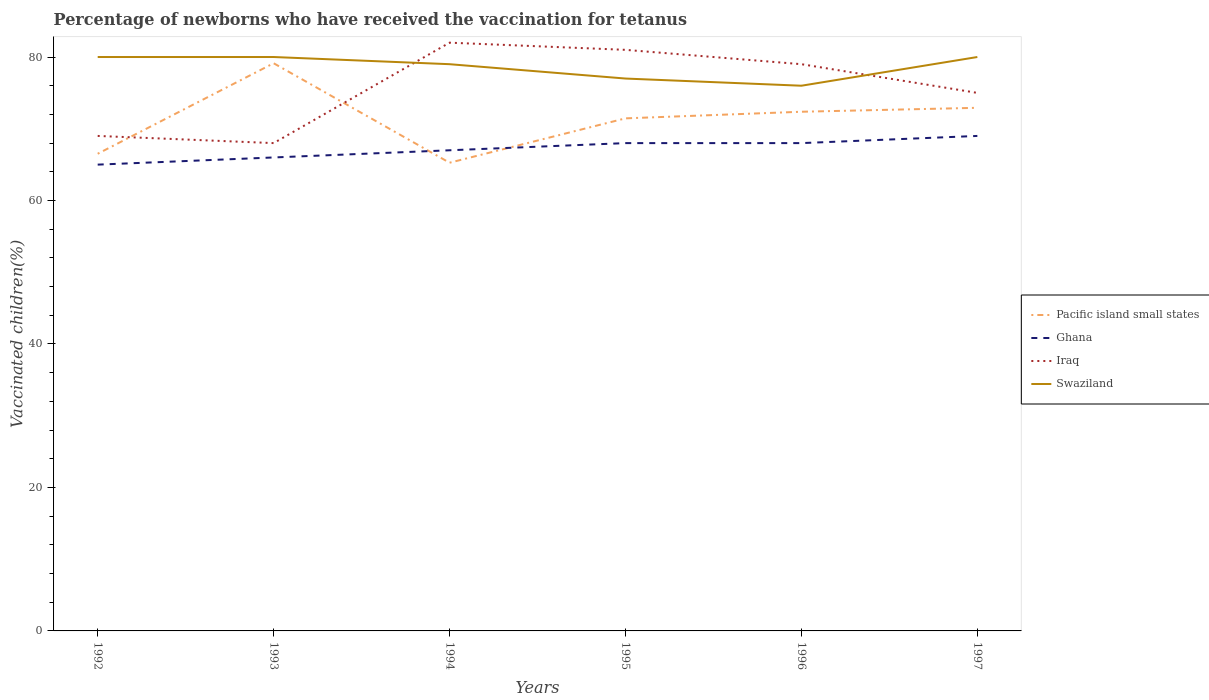Across all years, what is the maximum percentage of vaccinated children in Pacific island small states?
Make the answer very short. 65.27. What is the total percentage of vaccinated children in Pacific island small states in the graph?
Make the answer very short. -0.55. What is the difference between the highest and the second highest percentage of vaccinated children in Iraq?
Your answer should be compact. 14. Is the percentage of vaccinated children in Ghana strictly greater than the percentage of vaccinated children in Pacific island small states over the years?
Provide a short and direct response. No. How many years are there in the graph?
Keep it short and to the point. 6. What is the difference between two consecutive major ticks on the Y-axis?
Your answer should be compact. 20. Does the graph contain any zero values?
Give a very brief answer. No. Where does the legend appear in the graph?
Provide a short and direct response. Center right. How are the legend labels stacked?
Provide a succinct answer. Vertical. What is the title of the graph?
Ensure brevity in your answer.  Percentage of newborns who have received the vaccination for tetanus. Does "Bosnia and Herzegovina" appear as one of the legend labels in the graph?
Your answer should be very brief. No. What is the label or title of the X-axis?
Give a very brief answer. Years. What is the label or title of the Y-axis?
Offer a very short reply. Vaccinated children(%). What is the Vaccinated children(%) in Pacific island small states in 1992?
Provide a short and direct response. 66.51. What is the Vaccinated children(%) in Ghana in 1992?
Keep it short and to the point. 65. What is the Vaccinated children(%) of Iraq in 1992?
Make the answer very short. 69. What is the Vaccinated children(%) in Swaziland in 1992?
Your answer should be compact. 80. What is the Vaccinated children(%) in Pacific island small states in 1993?
Your answer should be very brief. 79.13. What is the Vaccinated children(%) in Swaziland in 1993?
Give a very brief answer. 80. What is the Vaccinated children(%) in Pacific island small states in 1994?
Offer a terse response. 65.27. What is the Vaccinated children(%) in Ghana in 1994?
Make the answer very short. 67. What is the Vaccinated children(%) in Swaziland in 1994?
Your answer should be compact. 79. What is the Vaccinated children(%) in Pacific island small states in 1995?
Keep it short and to the point. 71.45. What is the Vaccinated children(%) of Ghana in 1995?
Offer a terse response. 68. What is the Vaccinated children(%) in Iraq in 1995?
Give a very brief answer. 81. What is the Vaccinated children(%) of Pacific island small states in 1996?
Make the answer very short. 72.37. What is the Vaccinated children(%) in Iraq in 1996?
Ensure brevity in your answer.  79. What is the Vaccinated children(%) in Pacific island small states in 1997?
Provide a succinct answer. 72.92. What is the Vaccinated children(%) of Iraq in 1997?
Your answer should be very brief. 75. Across all years, what is the maximum Vaccinated children(%) in Pacific island small states?
Provide a short and direct response. 79.13. Across all years, what is the maximum Vaccinated children(%) of Iraq?
Give a very brief answer. 82. Across all years, what is the maximum Vaccinated children(%) in Swaziland?
Give a very brief answer. 80. Across all years, what is the minimum Vaccinated children(%) of Pacific island small states?
Offer a terse response. 65.27. What is the total Vaccinated children(%) of Pacific island small states in the graph?
Keep it short and to the point. 427.66. What is the total Vaccinated children(%) of Ghana in the graph?
Ensure brevity in your answer.  403. What is the total Vaccinated children(%) of Iraq in the graph?
Your answer should be very brief. 454. What is the total Vaccinated children(%) of Swaziland in the graph?
Offer a terse response. 472. What is the difference between the Vaccinated children(%) of Pacific island small states in 1992 and that in 1993?
Make the answer very short. -12.62. What is the difference between the Vaccinated children(%) in Ghana in 1992 and that in 1993?
Provide a succinct answer. -1. What is the difference between the Vaccinated children(%) in Iraq in 1992 and that in 1993?
Your answer should be very brief. 1. What is the difference between the Vaccinated children(%) of Pacific island small states in 1992 and that in 1994?
Your answer should be very brief. 1.25. What is the difference between the Vaccinated children(%) in Pacific island small states in 1992 and that in 1995?
Make the answer very short. -4.93. What is the difference between the Vaccinated children(%) of Ghana in 1992 and that in 1995?
Provide a succinct answer. -3. What is the difference between the Vaccinated children(%) in Pacific island small states in 1992 and that in 1996?
Give a very brief answer. -5.86. What is the difference between the Vaccinated children(%) in Ghana in 1992 and that in 1996?
Keep it short and to the point. -3. What is the difference between the Vaccinated children(%) in Iraq in 1992 and that in 1996?
Provide a short and direct response. -10. What is the difference between the Vaccinated children(%) of Swaziland in 1992 and that in 1996?
Offer a terse response. 4. What is the difference between the Vaccinated children(%) of Pacific island small states in 1992 and that in 1997?
Ensure brevity in your answer.  -6.41. What is the difference between the Vaccinated children(%) of Iraq in 1992 and that in 1997?
Keep it short and to the point. -6. What is the difference between the Vaccinated children(%) of Swaziland in 1992 and that in 1997?
Provide a short and direct response. 0. What is the difference between the Vaccinated children(%) of Pacific island small states in 1993 and that in 1994?
Offer a very short reply. 13.87. What is the difference between the Vaccinated children(%) of Pacific island small states in 1993 and that in 1995?
Ensure brevity in your answer.  7.68. What is the difference between the Vaccinated children(%) in Ghana in 1993 and that in 1995?
Your response must be concise. -2. What is the difference between the Vaccinated children(%) of Pacific island small states in 1993 and that in 1996?
Keep it short and to the point. 6.76. What is the difference between the Vaccinated children(%) of Iraq in 1993 and that in 1996?
Give a very brief answer. -11. What is the difference between the Vaccinated children(%) of Swaziland in 1993 and that in 1996?
Ensure brevity in your answer.  4. What is the difference between the Vaccinated children(%) of Pacific island small states in 1993 and that in 1997?
Give a very brief answer. 6.21. What is the difference between the Vaccinated children(%) of Swaziland in 1993 and that in 1997?
Provide a succinct answer. 0. What is the difference between the Vaccinated children(%) in Pacific island small states in 1994 and that in 1995?
Your response must be concise. -6.18. What is the difference between the Vaccinated children(%) in Swaziland in 1994 and that in 1995?
Offer a terse response. 2. What is the difference between the Vaccinated children(%) of Pacific island small states in 1994 and that in 1996?
Your answer should be compact. -7.11. What is the difference between the Vaccinated children(%) in Ghana in 1994 and that in 1996?
Keep it short and to the point. -1. What is the difference between the Vaccinated children(%) of Pacific island small states in 1994 and that in 1997?
Keep it short and to the point. -7.66. What is the difference between the Vaccinated children(%) of Ghana in 1994 and that in 1997?
Your response must be concise. -2. What is the difference between the Vaccinated children(%) in Pacific island small states in 1995 and that in 1996?
Make the answer very short. -0.92. What is the difference between the Vaccinated children(%) in Iraq in 1995 and that in 1996?
Your answer should be very brief. 2. What is the difference between the Vaccinated children(%) of Swaziland in 1995 and that in 1996?
Your answer should be compact. 1. What is the difference between the Vaccinated children(%) of Pacific island small states in 1995 and that in 1997?
Make the answer very short. -1.47. What is the difference between the Vaccinated children(%) of Ghana in 1995 and that in 1997?
Provide a short and direct response. -1. What is the difference between the Vaccinated children(%) of Iraq in 1995 and that in 1997?
Ensure brevity in your answer.  6. What is the difference between the Vaccinated children(%) in Swaziland in 1995 and that in 1997?
Make the answer very short. -3. What is the difference between the Vaccinated children(%) in Pacific island small states in 1996 and that in 1997?
Give a very brief answer. -0.55. What is the difference between the Vaccinated children(%) in Ghana in 1996 and that in 1997?
Provide a short and direct response. -1. What is the difference between the Vaccinated children(%) of Iraq in 1996 and that in 1997?
Your answer should be compact. 4. What is the difference between the Vaccinated children(%) of Swaziland in 1996 and that in 1997?
Ensure brevity in your answer.  -4. What is the difference between the Vaccinated children(%) in Pacific island small states in 1992 and the Vaccinated children(%) in Ghana in 1993?
Your answer should be compact. 0.51. What is the difference between the Vaccinated children(%) of Pacific island small states in 1992 and the Vaccinated children(%) of Iraq in 1993?
Provide a succinct answer. -1.49. What is the difference between the Vaccinated children(%) in Pacific island small states in 1992 and the Vaccinated children(%) in Swaziland in 1993?
Make the answer very short. -13.49. What is the difference between the Vaccinated children(%) of Iraq in 1992 and the Vaccinated children(%) of Swaziland in 1993?
Make the answer very short. -11. What is the difference between the Vaccinated children(%) in Pacific island small states in 1992 and the Vaccinated children(%) in Ghana in 1994?
Provide a short and direct response. -0.49. What is the difference between the Vaccinated children(%) of Pacific island small states in 1992 and the Vaccinated children(%) of Iraq in 1994?
Your answer should be compact. -15.49. What is the difference between the Vaccinated children(%) of Pacific island small states in 1992 and the Vaccinated children(%) of Swaziland in 1994?
Offer a very short reply. -12.49. What is the difference between the Vaccinated children(%) of Ghana in 1992 and the Vaccinated children(%) of Iraq in 1994?
Give a very brief answer. -17. What is the difference between the Vaccinated children(%) in Iraq in 1992 and the Vaccinated children(%) in Swaziland in 1994?
Your answer should be compact. -10. What is the difference between the Vaccinated children(%) in Pacific island small states in 1992 and the Vaccinated children(%) in Ghana in 1995?
Offer a terse response. -1.49. What is the difference between the Vaccinated children(%) of Pacific island small states in 1992 and the Vaccinated children(%) of Iraq in 1995?
Give a very brief answer. -14.49. What is the difference between the Vaccinated children(%) of Pacific island small states in 1992 and the Vaccinated children(%) of Swaziland in 1995?
Your answer should be compact. -10.49. What is the difference between the Vaccinated children(%) of Ghana in 1992 and the Vaccinated children(%) of Iraq in 1995?
Give a very brief answer. -16. What is the difference between the Vaccinated children(%) of Iraq in 1992 and the Vaccinated children(%) of Swaziland in 1995?
Ensure brevity in your answer.  -8. What is the difference between the Vaccinated children(%) of Pacific island small states in 1992 and the Vaccinated children(%) of Ghana in 1996?
Your answer should be very brief. -1.49. What is the difference between the Vaccinated children(%) of Pacific island small states in 1992 and the Vaccinated children(%) of Iraq in 1996?
Your response must be concise. -12.49. What is the difference between the Vaccinated children(%) of Pacific island small states in 1992 and the Vaccinated children(%) of Swaziland in 1996?
Provide a succinct answer. -9.49. What is the difference between the Vaccinated children(%) of Iraq in 1992 and the Vaccinated children(%) of Swaziland in 1996?
Offer a very short reply. -7. What is the difference between the Vaccinated children(%) of Pacific island small states in 1992 and the Vaccinated children(%) of Ghana in 1997?
Provide a short and direct response. -2.49. What is the difference between the Vaccinated children(%) of Pacific island small states in 1992 and the Vaccinated children(%) of Iraq in 1997?
Offer a terse response. -8.49. What is the difference between the Vaccinated children(%) of Pacific island small states in 1992 and the Vaccinated children(%) of Swaziland in 1997?
Give a very brief answer. -13.49. What is the difference between the Vaccinated children(%) of Ghana in 1992 and the Vaccinated children(%) of Swaziland in 1997?
Provide a short and direct response. -15. What is the difference between the Vaccinated children(%) in Iraq in 1992 and the Vaccinated children(%) in Swaziland in 1997?
Your response must be concise. -11. What is the difference between the Vaccinated children(%) of Pacific island small states in 1993 and the Vaccinated children(%) of Ghana in 1994?
Keep it short and to the point. 12.13. What is the difference between the Vaccinated children(%) in Pacific island small states in 1993 and the Vaccinated children(%) in Iraq in 1994?
Offer a terse response. -2.87. What is the difference between the Vaccinated children(%) of Pacific island small states in 1993 and the Vaccinated children(%) of Swaziland in 1994?
Your answer should be very brief. 0.13. What is the difference between the Vaccinated children(%) of Ghana in 1993 and the Vaccinated children(%) of Swaziland in 1994?
Ensure brevity in your answer.  -13. What is the difference between the Vaccinated children(%) in Pacific island small states in 1993 and the Vaccinated children(%) in Ghana in 1995?
Provide a short and direct response. 11.13. What is the difference between the Vaccinated children(%) of Pacific island small states in 1993 and the Vaccinated children(%) of Iraq in 1995?
Provide a succinct answer. -1.87. What is the difference between the Vaccinated children(%) in Pacific island small states in 1993 and the Vaccinated children(%) in Swaziland in 1995?
Provide a succinct answer. 2.13. What is the difference between the Vaccinated children(%) of Ghana in 1993 and the Vaccinated children(%) of Iraq in 1995?
Your answer should be compact. -15. What is the difference between the Vaccinated children(%) in Iraq in 1993 and the Vaccinated children(%) in Swaziland in 1995?
Provide a short and direct response. -9. What is the difference between the Vaccinated children(%) in Pacific island small states in 1993 and the Vaccinated children(%) in Ghana in 1996?
Keep it short and to the point. 11.13. What is the difference between the Vaccinated children(%) in Pacific island small states in 1993 and the Vaccinated children(%) in Iraq in 1996?
Make the answer very short. 0.13. What is the difference between the Vaccinated children(%) of Pacific island small states in 1993 and the Vaccinated children(%) of Swaziland in 1996?
Your response must be concise. 3.13. What is the difference between the Vaccinated children(%) of Ghana in 1993 and the Vaccinated children(%) of Swaziland in 1996?
Give a very brief answer. -10. What is the difference between the Vaccinated children(%) in Iraq in 1993 and the Vaccinated children(%) in Swaziland in 1996?
Offer a terse response. -8. What is the difference between the Vaccinated children(%) in Pacific island small states in 1993 and the Vaccinated children(%) in Ghana in 1997?
Keep it short and to the point. 10.13. What is the difference between the Vaccinated children(%) in Pacific island small states in 1993 and the Vaccinated children(%) in Iraq in 1997?
Provide a succinct answer. 4.13. What is the difference between the Vaccinated children(%) of Pacific island small states in 1993 and the Vaccinated children(%) of Swaziland in 1997?
Offer a very short reply. -0.87. What is the difference between the Vaccinated children(%) of Pacific island small states in 1994 and the Vaccinated children(%) of Ghana in 1995?
Your response must be concise. -2.73. What is the difference between the Vaccinated children(%) in Pacific island small states in 1994 and the Vaccinated children(%) in Iraq in 1995?
Your answer should be very brief. -15.73. What is the difference between the Vaccinated children(%) of Pacific island small states in 1994 and the Vaccinated children(%) of Swaziland in 1995?
Your answer should be compact. -11.73. What is the difference between the Vaccinated children(%) in Ghana in 1994 and the Vaccinated children(%) in Iraq in 1995?
Make the answer very short. -14. What is the difference between the Vaccinated children(%) of Ghana in 1994 and the Vaccinated children(%) of Swaziland in 1995?
Your answer should be very brief. -10. What is the difference between the Vaccinated children(%) of Pacific island small states in 1994 and the Vaccinated children(%) of Ghana in 1996?
Your answer should be very brief. -2.73. What is the difference between the Vaccinated children(%) in Pacific island small states in 1994 and the Vaccinated children(%) in Iraq in 1996?
Ensure brevity in your answer.  -13.73. What is the difference between the Vaccinated children(%) of Pacific island small states in 1994 and the Vaccinated children(%) of Swaziland in 1996?
Your response must be concise. -10.73. What is the difference between the Vaccinated children(%) in Iraq in 1994 and the Vaccinated children(%) in Swaziland in 1996?
Ensure brevity in your answer.  6. What is the difference between the Vaccinated children(%) in Pacific island small states in 1994 and the Vaccinated children(%) in Ghana in 1997?
Provide a short and direct response. -3.73. What is the difference between the Vaccinated children(%) in Pacific island small states in 1994 and the Vaccinated children(%) in Iraq in 1997?
Keep it short and to the point. -9.73. What is the difference between the Vaccinated children(%) of Pacific island small states in 1994 and the Vaccinated children(%) of Swaziland in 1997?
Offer a very short reply. -14.73. What is the difference between the Vaccinated children(%) of Iraq in 1994 and the Vaccinated children(%) of Swaziland in 1997?
Give a very brief answer. 2. What is the difference between the Vaccinated children(%) of Pacific island small states in 1995 and the Vaccinated children(%) of Ghana in 1996?
Provide a succinct answer. 3.45. What is the difference between the Vaccinated children(%) in Pacific island small states in 1995 and the Vaccinated children(%) in Iraq in 1996?
Offer a terse response. -7.55. What is the difference between the Vaccinated children(%) of Pacific island small states in 1995 and the Vaccinated children(%) of Swaziland in 1996?
Ensure brevity in your answer.  -4.55. What is the difference between the Vaccinated children(%) of Pacific island small states in 1995 and the Vaccinated children(%) of Ghana in 1997?
Make the answer very short. 2.45. What is the difference between the Vaccinated children(%) of Pacific island small states in 1995 and the Vaccinated children(%) of Iraq in 1997?
Ensure brevity in your answer.  -3.55. What is the difference between the Vaccinated children(%) of Pacific island small states in 1995 and the Vaccinated children(%) of Swaziland in 1997?
Make the answer very short. -8.55. What is the difference between the Vaccinated children(%) of Pacific island small states in 1996 and the Vaccinated children(%) of Ghana in 1997?
Offer a terse response. 3.37. What is the difference between the Vaccinated children(%) of Pacific island small states in 1996 and the Vaccinated children(%) of Iraq in 1997?
Keep it short and to the point. -2.63. What is the difference between the Vaccinated children(%) in Pacific island small states in 1996 and the Vaccinated children(%) in Swaziland in 1997?
Offer a very short reply. -7.63. What is the difference between the Vaccinated children(%) in Iraq in 1996 and the Vaccinated children(%) in Swaziland in 1997?
Provide a succinct answer. -1. What is the average Vaccinated children(%) of Pacific island small states per year?
Give a very brief answer. 71.28. What is the average Vaccinated children(%) in Ghana per year?
Give a very brief answer. 67.17. What is the average Vaccinated children(%) of Iraq per year?
Offer a very short reply. 75.67. What is the average Vaccinated children(%) of Swaziland per year?
Your answer should be very brief. 78.67. In the year 1992, what is the difference between the Vaccinated children(%) of Pacific island small states and Vaccinated children(%) of Ghana?
Offer a terse response. 1.51. In the year 1992, what is the difference between the Vaccinated children(%) in Pacific island small states and Vaccinated children(%) in Iraq?
Your response must be concise. -2.49. In the year 1992, what is the difference between the Vaccinated children(%) in Pacific island small states and Vaccinated children(%) in Swaziland?
Your response must be concise. -13.49. In the year 1992, what is the difference between the Vaccinated children(%) of Ghana and Vaccinated children(%) of Iraq?
Your response must be concise. -4. In the year 1992, what is the difference between the Vaccinated children(%) of Ghana and Vaccinated children(%) of Swaziland?
Provide a succinct answer. -15. In the year 1992, what is the difference between the Vaccinated children(%) of Iraq and Vaccinated children(%) of Swaziland?
Give a very brief answer. -11. In the year 1993, what is the difference between the Vaccinated children(%) in Pacific island small states and Vaccinated children(%) in Ghana?
Keep it short and to the point. 13.13. In the year 1993, what is the difference between the Vaccinated children(%) of Pacific island small states and Vaccinated children(%) of Iraq?
Your answer should be very brief. 11.13. In the year 1993, what is the difference between the Vaccinated children(%) in Pacific island small states and Vaccinated children(%) in Swaziland?
Offer a terse response. -0.87. In the year 1993, what is the difference between the Vaccinated children(%) in Ghana and Vaccinated children(%) in Swaziland?
Offer a very short reply. -14. In the year 1994, what is the difference between the Vaccinated children(%) of Pacific island small states and Vaccinated children(%) of Ghana?
Your response must be concise. -1.73. In the year 1994, what is the difference between the Vaccinated children(%) in Pacific island small states and Vaccinated children(%) in Iraq?
Your answer should be compact. -16.73. In the year 1994, what is the difference between the Vaccinated children(%) in Pacific island small states and Vaccinated children(%) in Swaziland?
Your answer should be compact. -13.73. In the year 1994, what is the difference between the Vaccinated children(%) of Ghana and Vaccinated children(%) of Swaziland?
Give a very brief answer. -12. In the year 1994, what is the difference between the Vaccinated children(%) in Iraq and Vaccinated children(%) in Swaziland?
Your answer should be compact. 3. In the year 1995, what is the difference between the Vaccinated children(%) of Pacific island small states and Vaccinated children(%) of Ghana?
Offer a very short reply. 3.45. In the year 1995, what is the difference between the Vaccinated children(%) of Pacific island small states and Vaccinated children(%) of Iraq?
Make the answer very short. -9.55. In the year 1995, what is the difference between the Vaccinated children(%) in Pacific island small states and Vaccinated children(%) in Swaziland?
Your answer should be very brief. -5.55. In the year 1995, what is the difference between the Vaccinated children(%) in Ghana and Vaccinated children(%) in Iraq?
Make the answer very short. -13. In the year 1996, what is the difference between the Vaccinated children(%) of Pacific island small states and Vaccinated children(%) of Ghana?
Provide a short and direct response. 4.37. In the year 1996, what is the difference between the Vaccinated children(%) of Pacific island small states and Vaccinated children(%) of Iraq?
Ensure brevity in your answer.  -6.63. In the year 1996, what is the difference between the Vaccinated children(%) of Pacific island small states and Vaccinated children(%) of Swaziland?
Your answer should be compact. -3.63. In the year 1997, what is the difference between the Vaccinated children(%) in Pacific island small states and Vaccinated children(%) in Ghana?
Offer a terse response. 3.92. In the year 1997, what is the difference between the Vaccinated children(%) in Pacific island small states and Vaccinated children(%) in Iraq?
Your response must be concise. -2.08. In the year 1997, what is the difference between the Vaccinated children(%) in Pacific island small states and Vaccinated children(%) in Swaziland?
Provide a succinct answer. -7.08. What is the ratio of the Vaccinated children(%) of Pacific island small states in 1992 to that in 1993?
Offer a very short reply. 0.84. What is the ratio of the Vaccinated children(%) of Ghana in 1992 to that in 1993?
Give a very brief answer. 0.98. What is the ratio of the Vaccinated children(%) of Iraq in 1992 to that in 1993?
Your answer should be very brief. 1.01. What is the ratio of the Vaccinated children(%) of Swaziland in 1992 to that in 1993?
Make the answer very short. 1. What is the ratio of the Vaccinated children(%) in Pacific island small states in 1992 to that in 1994?
Offer a terse response. 1.02. What is the ratio of the Vaccinated children(%) of Ghana in 1992 to that in 1994?
Give a very brief answer. 0.97. What is the ratio of the Vaccinated children(%) in Iraq in 1992 to that in 1994?
Your answer should be compact. 0.84. What is the ratio of the Vaccinated children(%) of Swaziland in 1992 to that in 1994?
Keep it short and to the point. 1.01. What is the ratio of the Vaccinated children(%) in Pacific island small states in 1992 to that in 1995?
Provide a succinct answer. 0.93. What is the ratio of the Vaccinated children(%) of Ghana in 1992 to that in 1995?
Ensure brevity in your answer.  0.96. What is the ratio of the Vaccinated children(%) of Iraq in 1992 to that in 1995?
Keep it short and to the point. 0.85. What is the ratio of the Vaccinated children(%) in Swaziland in 1992 to that in 1995?
Your answer should be very brief. 1.04. What is the ratio of the Vaccinated children(%) of Pacific island small states in 1992 to that in 1996?
Keep it short and to the point. 0.92. What is the ratio of the Vaccinated children(%) in Ghana in 1992 to that in 1996?
Your answer should be compact. 0.96. What is the ratio of the Vaccinated children(%) of Iraq in 1992 to that in 1996?
Offer a very short reply. 0.87. What is the ratio of the Vaccinated children(%) of Swaziland in 1992 to that in 1996?
Ensure brevity in your answer.  1.05. What is the ratio of the Vaccinated children(%) of Pacific island small states in 1992 to that in 1997?
Your response must be concise. 0.91. What is the ratio of the Vaccinated children(%) of Ghana in 1992 to that in 1997?
Provide a succinct answer. 0.94. What is the ratio of the Vaccinated children(%) in Pacific island small states in 1993 to that in 1994?
Your response must be concise. 1.21. What is the ratio of the Vaccinated children(%) in Ghana in 1993 to that in 1994?
Keep it short and to the point. 0.99. What is the ratio of the Vaccinated children(%) of Iraq in 1993 to that in 1994?
Your response must be concise. 0.83. What is the ratio of the Vaccinated children(%) in Swaziland in 1993 to that in 1994?
Provide a short and direct response. 1.01. What is the ratio of the Vaccinated children(%) of Pacific island small states in 1993 to that in 1995?
Your answer should be very brief. 1.11. What is the ratio of the Vaccinated children(%) of Ghana in 1993 to that in 1995?
Keep it short and to the point. 0.97. What is the ratio of the Vaccinated children(%) of Iraq in 1993 to that in 1995?
Offer a very short reply. 0.84. What is the ratio of the Vaccinated children(%) of Swaziland in 1993 to that in 1995?
Make the answer very short. 1.04. What is the ratio of the Vaccinated children(%) of Pacific island small states in 1993 to that in 1996?
Provide a succinct answer. 1.09. What is the ratio of the Vaccinated children(%) in Ghana in 1993 to that in 1996?
Your answer should be very brief. 0.97. What is the ratio of the Vaccinated children(%) of Iraq in 1993 to that in 1996?
Provide a short and direct response. 0.86. What is the ratio of the Vaccinated children(%) of Swaziland in 1993 to that in 1996?
Your response must be concise. 1.05. What is the ratio of the Vaccinated children(%) in Pacific island small states in 1993 to that in 1997?
Your response must be concise. 1.09. What is the ratio of the Vaccinated children(%) of Ghana in 1993 to that in 1997?
Provide a short and direct response. 0.96. What is the ratio of the Vaccinated children(%) in Iraq in 1993 to that in 1997?
Keep it short and to the point. 0.91. What is the ratio of the Vaccinated children(%) in Pacific island small states in 1994 to that in 1995?
Provide a succinct answer. 0.91. What is the ratio of the Vaccinated children(%) of Ghana in 1994 to that in 1995?
Your response must be concise. 0.99. What is the ratio of the Vaccinated children(%) in Iraq in 1994 to that in 1995?
Make the answer very short. 1.01. What is the ratio of the Vaccinated children(%) in Swaziland in 1994 to that in 1995?
Offer a terse response. 1.03. What is the ratio of the Vaccinated children(%) in Pacific island small states in 1994 to that in 1996?
Your response must be concise. 0.9. What is the ratio of the Vaccinated children(%) in Ghana in 1994 to that in 1996?
Make the answer very short. 0.99. What is the ratio of the Vaccinated children(%) of Iraq in 1994 to that in 1996?
Give a very brief answer. 1.04. What is the ratio of the Vaccinated children(%) of Swaziland in 1994 to that in 1996?
Keep it short and to the point. 1.04. What is the ratio of the Vaccinated children(%) in Pacific island small states in 1994 to that in 1997?
Provide a succinct answer. 0.9. What is the ratio of the Vaccinated children(%) of Iraq in 1994 to that in 1997?
Keep it short and to the point. 1.09. What is the ratio of the Vaccinated children(%) of Swaziland in 1994 to that in 1997?
Your response must be concise. 0.99. What is the ratio of the Vaccinated children(%) of Pacific island small states in 1995 to that in 1996?
Give a very brief answer. 0.99. What is the ratio of the Vaccinated children(%) in Iraq in 1995 to that in 1996?
Your response must be concise. 1.03. What is the ratio of the Vaccinated children(%) in Swaziland in 1995 to that in 1996?
Provide a short and direct response. 1.01. What is the ratio of the Vaccinated children(%) in Pacific island small states in 1995 to that in 1997?
Your answer should be compact. 0.98. What is the ratio of the Vaccinated children(%) in Ghana in 1995 to that in 1997?
Make the answer very short. 0.99. What is the ratio of the Vaccinated children(%) in Iraq in 1995 to that in 1997?
Your answer should be very brief. 1.08. What is the ratio of the Vaccinated children(%) in Swaziland in 1995 to that in 1997?
Keep it short and to the point. 0.96. What is the ratio of the Vaccinated children(%) in Ghana in 1996 to that in 1997?
Offer a very short reply. 0.99. What is the ratio of the Vaccinated children(%) of Iraq in 1996 to that in 1997?
Provide a succinct answer. 1.05. What is the difference between the highest and the second highest Vaccinated children(%) of Pacific island small states?
Your answer should be compact. 6.21. What is the difference between the highest and the second highest Vaccinated children(%) in Ghana?
Make the answer very short. 1. What is the difference between the highest and the second highest Vaccinated children(%) in Swaziland?
Ensure brevity in your answer.  0. What is the difference between the highest and the lowest Vaccinated children(%) of Pacific island small states?
Your answer should be very brief. 13.87. What is the difference between the highest and the lowest Vaccinated children(%) in Ghana?
Ensure brevity in your answer.  4. 